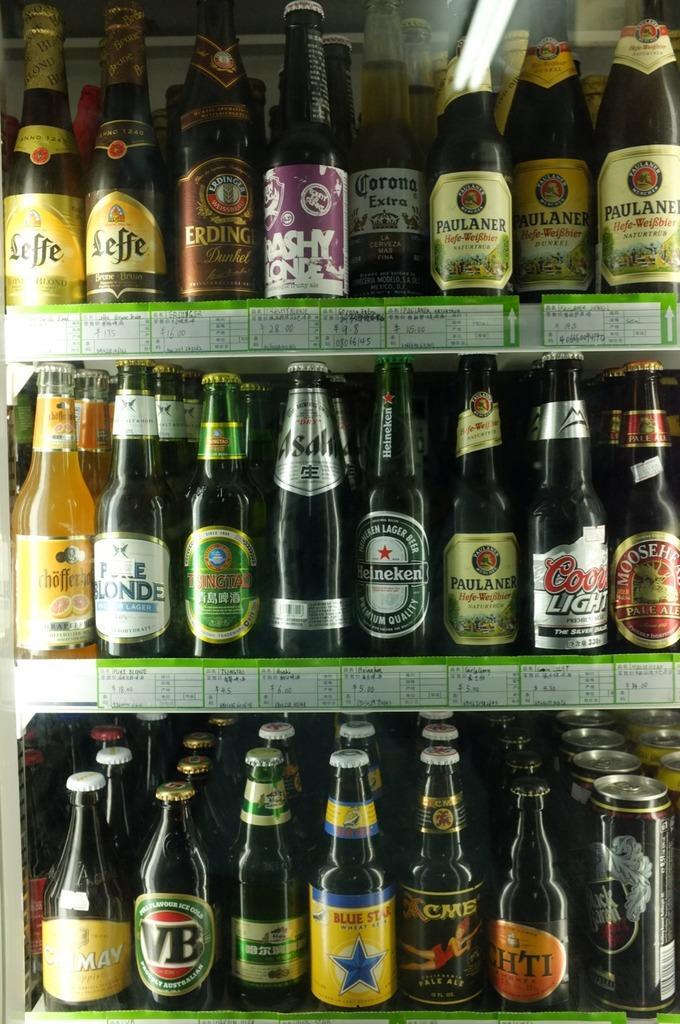In one or two sentences, can you explain what this image depicts? In this image we have a group of wine bottles in the back with the kids and the labels. 